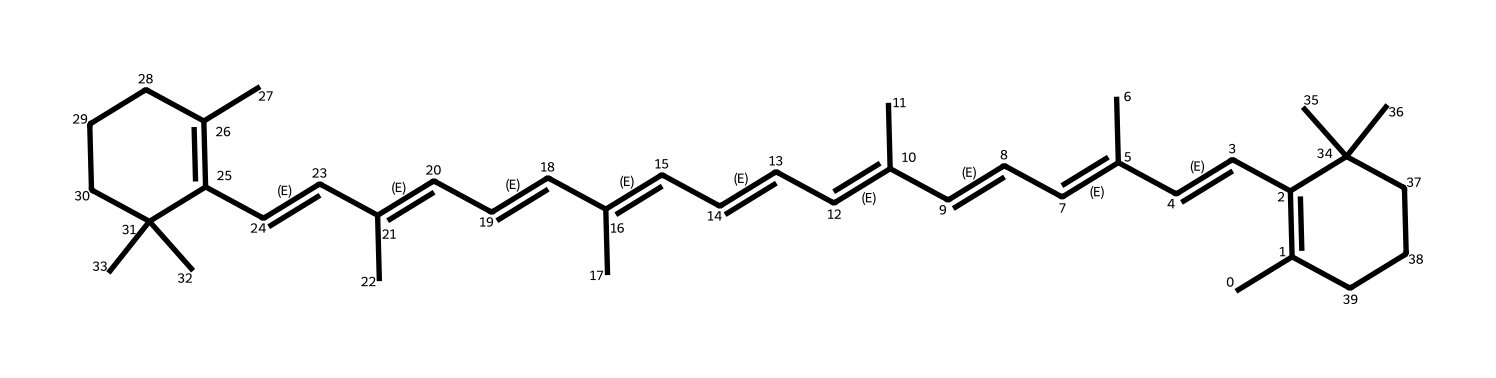What is the molecular formula of beta-carotene? The SMILES representation can be broken down to identify the number of different atoms present. Count the carbon (C) and hydrogen (H) atoms; in this case, there are 40 carbon atoms and 56 hydrogen atoms. Therefore, the molecular formula is C40H56.
Answer: C40H56 How many double bonds are present in beta-carotene? To determine the number of double bonds, count the "C=C" pairs present in the structure. In this SMILES representation, there are 11 double bonds (indicated by the '=' signs).
Answer: 11 Which part of beta-carotene is responsible for its antioxidant properties? The presence of conjugated double bonds in beta-carotene plays a critical role in its antioxidant properties. Specifically, the extended system of alternating double bonds allows for stabilization of free radicals.
Answer: conjugated double bonds What is the significance of beta-carotene as a precursor to vitamin A? Beta-carotene is converted into vitamin A (retinol) in the body, essential for various biological functions, including vision, immunity, and skin health. This transformation occurs through enzymatic conversion in the small intestine.
Answer: precursor to vitamin A What does the ring structure in beta-carotene indicate? The presence of a cyclic structure in beta-carotene signifies that it has a stabilization effect on the compound, which can influence its reactivity and antioxidant capacity. Specifically, the ring system contributes to the overall stability of the molecule.
Answer: stabilization effect What type of compound is beta-carotene classified as? Given its structure and properties, beta-carotene is classified as a carotenoid, a subclass of terpenoids, which are known for their antioxidant properties and roles in pigmentation.
Answer: carotenoid 